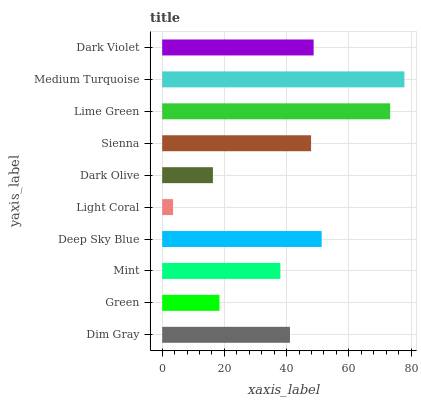Is Light Coral the minimum?
Answer yes or no. Yes. Is Medium Turquoise the maximum?
Answer yes or no. Yes. Is Green the minimum?
Answer yes or no. No. Is Green the maximum?
Answer yes or no. No. Is Dim Gray greater than Green?
Answer yes or no. Yes. Is Green less than Dim Gray?
Answer yes or no. Yes. Is Green greater than Dim Gray?
Answer yes or no. No. Is Dim Gray less than Green?
Answer yes or no. No. Is Sienna the high median?
Answer yes or no. Yes. Is Dim Gray the low median?
Answer yes or no. Yes. Is Mint the high median?
Answer yes or no. No. Is Mint the low median?
Answer yes or no. No. 